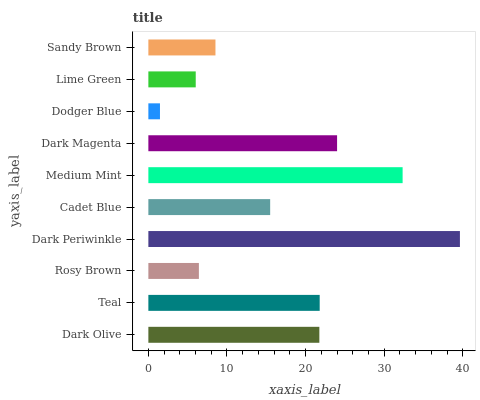Is Dodger Blue the minimum?
Answer yes or no. Yes. Is Dark Periwinkle the maximum?
Answer yes or no. Yes. Is Teal the minimum?
Answer yes or no. No. Is Teal the maximum?
Answer yes or no. No. Is Teal greater than Dark Olive?
Answer yes or no. Yes. Is Dark Olive less than Teal?
Answer yes or no. Yes. Is Dark Olive greater than Teal?
Answer yes or no. No. Is Teal less than Dark Olive?
Answer yes or no. No. Is Dark Olive the high median?
Answer yes or no. Yes. Is Cadet Blue the low median?
Answer yes or no. Yes. Is Rosy Brown the high median?
Answer yes or no. No. Is Medium Mint the low median?
Answer yes or no. No. 